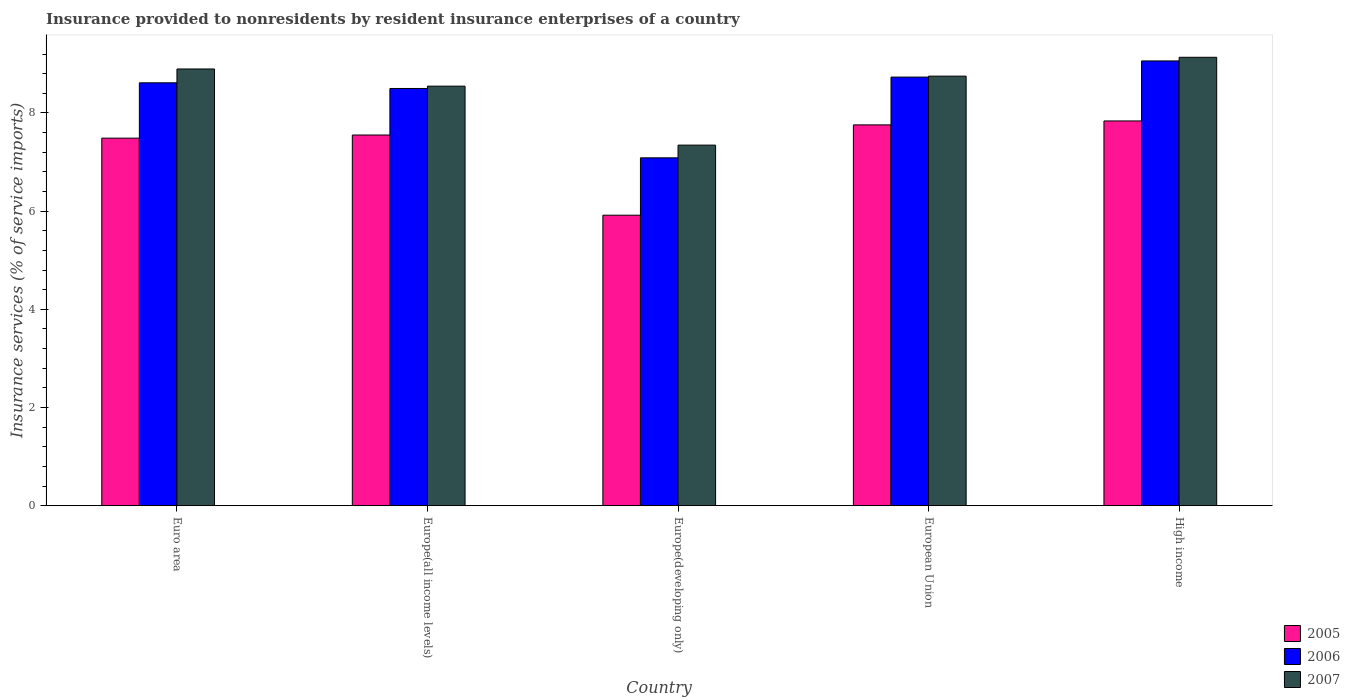How many different coloured bars are there?
Provide a short and direct response. 3. Are the number of bars per tick equal to the number of legend labels?
Give a very brief answer. Yes. What is the label of the 1st group of bars from the left?
Your answer should be very brief. Euro area. In how many cases, is the number of bars for a given country not equal to the number of legend labels?
Provide a succinct answer. 0. What is the insurance provided to nonresidents in 2006 in Europe(all income levels)?
Offer a very short reply. 8.5. Across all countries, what is the maximum insurance provided to nonresidents in 2005?
Make the answer very short. 7.84. Across all countries, what is the minimum insurance provided to nonresidents in 2006?
Make the answer very short. 7.09. In which country was the insurance provided to nonresidents in 2005 maximum?
Offer a terse response. High income. In which country was the insurance provided to nonresidents in 2005 minimum?
Ensure brevity in your answer.  Europe(developing only). What is the total insurance provided to nonresidents in 2005 in the graph?
Your answer should be very brief. 36.55. What is the difference between the insurance provided to nonresidents in 2005 in Europe(all income levels) and that in Europe(developing only)?
Your answer should be very brief. 1.63. What is the difference between the insurance provided to nonresidents in 2005 in European Union and the insurance provided to nonresidents in 2006 in Europe(all income levels)?
Offer a very short reply. -0.74. What is the average insurance provided to nonresidents in 2007 per country?
Your answer should be very brief. 8.53. What is the difference between the insurance provided to nonresidents of/in 2005 and insurance provided to nonresidents of/in 2007 in European Union?
Keep it short and to the point. -0.99. In how many countries, is the insurance provided to nonresidents in 2005 greater than 6.8 %?
Your answer should be compact. 4. What is the ratio of the insurance provided to nonresidents in 2007 in Europe(all income levels) to that in High income?
Keep it short and to the point. 0.94. Is the difference between the insurance provided to nonresidents in 2005 in Europe(all income levels) and European Union greater than the difference between the insurance provided to nonresidents in 2007 in Europe(all income levels) and European Union?
Provide a succinct answer. No. What is the difference between the highest and the second highest insurance provided to nonresidents in 2005?
Make the answer very short. -0.21. What is the difference between the highest and the lowest insurance provided to nonresidents in 2005?
Make the answer very short. 1.92. What does the 3rd bar from the left in High income represents?
Offer a very short reply. 2007. How many countries are there in the graph?
Provide a succinct answer. 5. What is the difference between two consecutive major ticks on the Y-axis?
Keep it short and to the point. 2. Are the values on the major ticks of Y-axis written in scientific E-notation?
Ensure brevity in your answer.  No. Does the graph contain any zero values?
Your answer should be compact. No. Where does the legend appear in the graph?
Keep it short and to the point. Bottom right. What is the title of the graph?
Keep it short and to the point. Insurance provided to nonresidents by resident insurance enterprises of a country. What is the label or title of the Y-axis?
Offer a very short reply. Insurance services (% of service imports). What is the Insurance services (% of service imports) in 2005 in Euro area?
Your response must be concise. 7.49. What is the Insurance services (% of service imports) of 2006 in Euro area?
Provide a short and direct response. 8.61. What is the Insurance services (% of service imports) of 2007 in Euro area?
Your response must be concise. 8.9. What is the Insurance services (% of service imports) of 2005 in Europe(all income levels)?
Your answer should be compact. 7.55. What is the Insurance services (% of service imports) of 2006 in Europe(all income levels)?
Your response must be concise. 8.5. What is the Insurance services (% of service imports) in 2007 in Europe(all income levels)?
Your response must be concise. 8.55. What is the Insurance services (% of service imports) in 2005 in Europe(developing only)?
Your response must be concise. 5.92. What is the Insurance services (% of service imports) in 2006 in Europe(developing only)?
Keep it short and to the point. 7.09. What is the Insurance services (% of service imports) of 2007 in Europe(developing only)?
Provide a succinct answer. 7.34. What is the Insurance services (% of service imports) of 2005 in European Union?
Give a very brief answer. 7.76. What is the Insurance services (% of service imports) of 2006 in European Union?
Ensure brevity in your answer.  8.73. What is the Insurance services (% of service imports) in 2007 in European Union?
Your answer should be very brief. 8.75. What is the Insurance services (% of service imports) of 2005 in High income?
Offer a very short reply. 7.84. What is the Insurance services (% of service imports) in 2006 in High income?
Your answer should be very brief. 9.06. What is the Insurance services (% of service imports) of 2007 in High income?
Your answer should be compact. 9.13. Across all countries, what is the maximum Insurance services (% of service imports) of 2005?
Keep it short and to the point. 7.84. Across all countries, what is the maximum Insurance services (% of service imports) of 2006?
Keep it short and to the point. 9.06. Across all countries, what is the maximum Insurance services (% of service imports) in 2007?
Keep it short and to the point. 9.13. Across all countries, what is the minimum Insurance services (% of service imports) in 2005?
Provide a succinct answer. 5.92. Across all countries, what is the minimum Insurance services (% of service imports) of 2006?
Provide a succinct answer. 7.09. Across all countries, what is the minimum Insurance services (% of service imports) in 2007?
Your answer should be compact. 7.34. What is the total Insurance services (% of service imports) of 2005 in the graph?
Provide a short and direct response. 36.55. What is the total Insurance services (% of service imports) of 2006 in the graph?
Provide a succinct answer. 41.99. What is the total Insurance services (% of service imports) in 2007 in the graph?
Your answer should be compact. 42.67. What is the difference between the Insurance services (% of service imports) of 2005 in Euro area and that in Europe(all income levels)?
Your answer should be compact. -0.06. What is the difference between the Insurance services (% of service imports) of 2006 in Euro area and that in Europe(all income levels)?
Provide a short and direct response. 0.12. What is the difference between the Insurance services (% of service imports) in 2007 in Euro area and that in Europe(all income levels)?
Make the answer very short. 0.35. What is the difference between the Insurance services (% of service imports) in 2005 in Euro area and that in Europe(developing only)?
Give a very brief answer. 1.57. What is the difference between the Insurance services (% of service imports) in 2006 in Euro area and that in Europe(developing only)?
Keep it short and to the point. 1.53. What is the difference between the Insurance services (% of service imports) in 2007 in Euro area and that in Europe(developing only)?
Offer a terse response. 1.55. What is the difference between the Insurance services (% of service imports) of 2005 in Euro area and that in European Union?
Your answer should be very brief. -0.27. What is the difference between the Insurance services (% of service imports) of 2006 in Euro area and that in European Union?
Make the answer very short. -0.12. What is the difference between the Insurance services (% of service imports) in 2007 in Euro area and that in European Union?
Offer a very short reply. 0.15. What is the difference between the Insurance services (% of service imports) in 2005 in Euro area and that in High income?
Offer a terse response. -0.35. What is the difference between the Insurance services (% of service imports) in 2006 in Euro area and that in High income?
Your answer should be compact. -0.45. What is the difference between the Insurance services (% of service imports) of 2007 in Euro area and that in High income?
Offer a very short reply. -0.24. What is the difference between the Insurance services (% of service imports) of 2005 in Europe(all income levels) and that in Europe(developing only)?
Give a very brief answer. 1.63. What is the difference between the Insurance services (% of service imports) in 2006 in Europe(all income levels) and that in Europe(developing only)?
Provide a succinct answer. 1.41. What is the difference between the Insurance services (% of service imports) in 2007 in Europe(all income levels) and that in Europe(developing only)?
Provide a short and direct response. 1.2. What is the difference between the Insurance services (% of service imports) in 2005 in Europe(all income levels) and that in European Union?
Provide a succinct answer. -0.21. What is the difference between the Insurance services (% of service imports) of 2006 in Europe(all income levels) and that in European Union?
Your response must be concise. -0.23. What is the difference between the Insurance services (% of service imports) of 2007 in Europe(all income levels) and that in European Union?
Your answer should be very brief. -0.2. What is the difference between the Insurance services (% of service imports) in 2005 in Europe(all income levels) and that in High income?
Give a very brief answer. -0.29. What is the difference between the Insurance services (% of service imports) of 2006 in Europe(all income levels) and that in High income?
Your response must be concise. -0.56. What is the difference between the Insurance services (% of service imports) in 2007 in Europe(all income levels) and that in High income?
Your answer should be very brief. -0.59. What is the difference between the Insurance services (% of service imports) in 2005 in Europe(developing only) and that in European Union?
Offer a terse response. -1.84. What is the difference between the Insurance services (% of service imports) in 2006 in Europe(developing only) and that in European Union?
Keep it short and to the point. -1.64. What is the difference between the Insurance services (% of service imports) in 2007 in Europe(developing only) and that in European Union?
Provide a succinct answer. -1.41. What is the difference between the Insurance services (% of service imports) of 2005 in Europe(developing only) and that in High income?
Make the answer very short. -1.92. What is the difference between the Insurance services (% of service imports) in 2006 in Europe(developing only) and that in High income?
Provide a succinct answer. -1.97. What is the difference between the Insurance services (% of service imports) of 2007 in Europe(developing only) and that in High income?
Your response must be concise. -1.79. What is the difference between the Insurance services (% of service imports) in 2005 in European Union and that in High income?
Your response must be concise. -0.08. What is the difference between the Insurance services (% of service imports) in 2006 in European Union and that in High income?
Offer a very short reply. -0.33. What is the difference between the Insurance services (% of service imports) in 2007 in European Union and that in High income?
Offer a terse response. -0.38. What is the difference between the Insurance services (% of service imports) in 2005 in Euro area and the Insurance services (% of service imports) in 2006 in Europe(all income levels)?
Make the answer very short. -1.01. What is the difference between the Insurance services (% of service imports) of 2005 in Euro area and the Insurance services (% of service imports) of 2007 in Europe(all income levels)?
Ensure brevity in your answer.  -1.06. What is the difference between the Insurance services (% of service imports) in 2006 in Euro area and the Insurance services (% of service imports) in 2007 in Europe(all income levels)?
Your answer should be compact. 0.07. What is the difference between the Insurance services (% of service imports) of 2005 in Euro area and the Insurance services (% of service imports) of 2006 in Europe(developing only)?
Your answer should be compact. 0.4. What is the difference between the Insurance services (% of service imports) in 2005 in Euro area and the Insurance services (% of service imports) in 2007 in Europe(developing only)?
Your response must be concise. 0.14. What is the difference between the Insurance services (% of service imports) of 2006 in Euro area and the Insurance services (% of service imports) of 2007 in Europe(developing only)?
Offer a terse response. 1.27. What is the difference between the Insurance services (% of service imports) in 2005 in Euro area and the Insurance services (% of service imports) in 2006 in European Union?
Make the answer very short. -1.24. What is the difference between the Insurance services (% of service imports) of 2005 in Euro area and the Insurance services (% of service imports) of 2007 in European Union?
Provide a succinct answer. -1.26. What is the difference between the Insurance services (% of service imports) in 2006 in Euro area and the Insurance services (% of service imports) in 2007 in European Union?
Offer a terse response. -0.14. What is the difference between the Insurance services (% of service imports) of 2005 in Euro area and the Insurance services (% of service imports) of 2006 in High income?
Your answer should be compact. -1.57. What is the difference between the Insurance services (% of service imports) of 2005 in Euro area and the Insurance services (% of service imports) of 2007 in High income?
Your answer should be compact. -1.65. What is the difference between the Insurance services (% of service imports) of 2006 in Euro area and the Insurance services (% of service imports) of 2007 in High income?
Your answer should be compact. -0.52. What is the difference between the Insurance services (% of service imports) in 2005 in Europe(all income levels) and the Insurance services (% of service imports) in 2006 in Europe(developing only)?
Offer a terse response. 0.47. What is the difference between the Insurance services (% of service imports) in 2005 in Europe(all income levels) and the Insurance services (% of service imports) in 2007 in Europe(developing only)?
Your answer should be compact. 0.21. What is the difference between the Insurance services (% of service imports) of 2006 in Europe(all income levels) and the Insurance services (% of service imports) of 2007 in Europe(developing only)?
Your response must be concise. 1.15. What is the difference between the Insurance services (% of service imports) of 2005 in Europe(all income levels) and the Insurance services (% of service imports) of 2006 in European Union?
Your answer should be very brief. -1.18. What is the difference between the Insurance services (% of service imports) of 2005 in Europe(all income levels) and the Insurance services (% of service imports) of 2007 in European Union?
Your response must be concise. -1.2. What is the difference between the Insurance services (% of service imports) of 2006 in Europe(all income levels) and the Insurance services (% of service imports) of 2007 in European Union?
Ensure brevity in your answer.  -0.25. What is the difference between the Insurance services (% of service imports) of 2005 in Europe(all income levels) and the Insurance services (% of service imports) of 2006 in High income?
Provide a short and direct response. -1.51. What is the difference between the Insurance services (% of service imports) in 2005 in Europe(all income levels) and the Insurance services (% of service imports) in 2007 in High income?
Make the answer very short. -1.58. What is the difference between the Insurance services (% of service imports) of 2006 in Europe(all income levels) and the Insurance services (% of service imports) of 2007 in High income?
Provide a succinct answer. -0.64. What is the difference between the Insurance services (% of service imports) of 2005 in Europe(developing only) and the Insurance services (% of service imports) of 2006 in European Union?
Give a very brief answer. -2.81. What is the difference between the Insurance services (% of service imports) in 2005 in Europe(developing only) and the Insurance services (% of service imports) in 2007 in European Union?
Provide a succinct answer. -2.83. What is the difference between the Insurance services (% of service imports) in 2006 in Europe(developing only) and the Insurance services (% of service imports) in 2007 in European Union?
Provide a succinct answer. -1.66. What is the difference between the Insurance services (% of service imports) in 2005 in Europe(developing only) and the Insurance services (% of service imports) in 2006 in High income?
Your response must be concise. -3.14. What is the difference between the Insurance services (% of service imports) in 2005 in Europe(developing only) and the Insurance services (% of service imports) in 2007 in High income?
Ensure brevity in your answer.  -3.22. What is the difference between the Insurance services (% of service imports) of 2006 in Europe(developing only) and the Insurance services (% of service imports) of 2007 in High income?
Offer a very short reply. -2.05. What is the difference between the Insurance services (% of service imports) in 2005 in European Union and the Insurance services (% of service imports) in 2006 in High income?
Offer a terse response. -1.3. What is the difference between the Insurance services (% of service imports) of 2005 in European Union and the Insurance services (% of service imports) of 2007 in High income?
Offer a terse response. -1.38. What is the difference between the Insurance services (% of service imports) of 2006 in European Union and the Insurance services (% of service imports) of 2007 in High income?
Provide a succinct answer. -0.4. What is the average Insurance services (% of service imports) in 2005 per country?
Keep it short and to the point. 7.31. What is the average Insurance services (% of service imports) in 2006 per country?
Ensure brevity in your answer.  8.4. What is the average Insurance services (% of service imports) of 2007 per country?
Provide a short and direct response. 8.53. What is the difference between the Insurance services (% of service imports) in 2005 and Insurance services (% of service imports) in 2006 in Euro area?
Provide a short and direct response. -1.13. What is the difference between the Insurance services (% of service imports) of 2005 and Insurance services (% of service imports) of 2007 in Euro area?
Keep it short and to the point. -1.41. What is the difference between the Insurance services (% of service imports) in 2006 and Insurance services (% of service imports) in 2007 in Euro area?
Give a very brief answer. -0.28. What is the difference between the Insurance services (% of service imports) of 2005 and Insurance services (% of service imports) of 2006 in Europe(all income levels)?
Keep it short and to the point. -0.95. What is the difference between the Insurance services (% of service imports) of 2005 and Insurance services (% of service imports) of 2007 in Europe(all income levels)?
Your answer should be compact. -1. What is the difference between the Insurance services (% of service imports) in 2006 and Insurance services (% of service imports) in 2007 in Europe(all income levels)?
Provide a short and direct response. -0.05. What is the difference between the Insurance services (% of service imports) in 2005 and Insurance services (% of service imports) in 2006 in Europe(developing only)?
Keep it short and to the point. -1.17. What is the difference between the Insurance services (% of service imports) of 2005 and Insurance services (% of service imports) of 2007 in Europe(developing only)?
Ensure brevity in your answer.  -1.43. What is the difference between the Insurance services (% of service imports) in 2006 and Insurance services (% of service imports) in 2007 in Europe(developing only)?
Your answer should be compact. -0.26. What is the difference between the Insurance services (% of service imports) in 2005 and Insurance services (% of service imports) in 2006 in European Union?
Offer a terse response. -0.97. What is the difference between the Insurance services (% of service imports) of 2005 and Insurance services (% of service imports) of 2007 in European Union?
Give a very brief answer. -0.99. What is the difference between the Insurance services (% of service imports) in 2006 and Insurance services (% of service imports) in 2007 in European Union?
Offer a terse response. -0.02. What is the difference between the Insurance services (% of service imports) of 2005 and Insurance services (% of service imports) of 2006 in High income?
Offer a very short reply. -1.22. What is the difference between the Insurance services (% of service imports) of 2005 and Insurance services (% of service imports) of 2007 in High income?
Keep it short and to the point. -1.3. What is the difference between the Insurance services (% of service imports) in 2006 and Insurance services (% of service imports) in 2007 in High income?
Offer a terse response. -0.07. What is the ratio of the Insurance services (% of service imports) of 2005 in Euro area to that in Europe(all income levels)?
Ensure brevity in your answer.  0.99. What is the ratio of the Insurance services (% of service imports) in 2006 in Euro area to that in Europe(all income levels)?
Your answer should be very brief. 1.01. What is the ratio of the Insurance services (% of service imports) of 2007 in Euro area to that in Europe(all income levels)?
Make the answer very short. 1.04. What is the ratio of the Insurance services (% of service imports) in 2005 in Euro area to that in Europe(developing only)?
Offer a very short reply. 1.27. What is the ratio of the Insurance services (% of service imports) in 2006 in Euro area to that in Europe(developing only)?
Give a very brief answer. 1.22. What is the ratio of the Insurance services (% of service imports) in 2007 in Euro area to that in Europe(developing only)?
Provide a short and direct response. 1.21. What is the ratio of the Insurance services (% of service imports) of 2005 in Euro area to that in European Union?
Offer a terse response. 0.97. What is the ratio of the Insurance services (% of service imports) in 2006 in Euro area to that in European Union?
Provide a succinct answer. 0.99. What is the ratio of the Insurance services (% of service imports) in 2007 in Euro area to that in European Union?
Offer a very short reply. 1.02. What is the ratio of the Insurance services (% of service imports) in 2005 in Euro area to that in High income?
Keep it short and to the point. 0.96. What is the ratio of the Insurance services (% of service imports) of 2006 in Euro area to that in High income?
Give a very brief answer. 0.95. What is the ratio of the Insurance services (% of service imports) of 2007 in Euro area to that in High income?
Provide a succinct answer. 0.97. What is the ratio of the Insurance services (% of service imports) of 2005 in Europe(all income levels) to that in Europe(developing only)?
Your answer should be very brief. 1.28. What is the ratio of the Insurance services (% of service imports) in 2006 in Europe(all income levels) to that in Europe(developing only)?
Provide a succinct answer. 1.2. What is the ratio of the Insurance services (% of service imports) of 2007 in Europe(all income levels) to that in Europe(developing only)?
Give a very brief answer. 1.16. What is the ratio of the Insurance services (% of service imports) of 2005 in Europe(all income levels) to that in European Union?
Your response must be concise. 0.97. What is the ratio of the Insurance services (% of service imports) of 2006 in Europe(all income levels) to that in European Union?
Provide a short and direct response. 0.97. What is the ratio of the Insurance services (% of service imports) in 2007 in Europe(all income levels) to that in European Union?
Offer a terse response. 0.98. What is the ratio of the Insurance services (% of service imports) of 2005 in Europe(all income levels) to that in High income?
Give a very brief answer. 0.96. What is the ratio of the Insurance services (% of service imports) of 2006 in Europe(all income levels) to that in High income?
Your answer should be very brief. 0.94. What is the ratio of the Insurance services (% of service imports) of 2007 in Europe(all income levels) to that in High income?
Offer a very short reply. 0.94. What is the ratio of the Insurance services (% of service imports) in 2005 in Europe(developing only) to that in European Union?
Your answer should be very brief. 0.76. What is the ratio of the Insurance services (% of service imports) in 2006 in Europe(developing only) to that in European Union?
Ensure brevity in your answer.  0.81. What is the ratio of the Insurance services (% of service imports) of 2007 in Europe(developing only) to that in European Union?
Ensure brevity in your answer.  0.84. What is the ratio of the Insurance services (% of service imports) in 2005 in Europe(developing only) to that in High income?
Provide a succinct answer. 0.76. What is the ratio of the Insurance services (% of service imports) in 2006 in Europe(developing only) to that in High income?
Keep it short and to the point. 0.78. What is the ratio of the Insurance services (% of service imports) of 2007 in Europe(developing only) to that in High income?
Your answer should be compact. 0.8. What is the ratio of the Insurance services (% of service imports) in 2005 in European Union to that in High income?
Keep it short and to the point. 0.99. What is the ratio of the Insurance services (% of service imports) in 2006 in European Union to that in High income?
Offer a very short reply. 0.96. What is the ratio of the Insurance services (% of service imports) of 2007 in European Union to that in High income?
Offer a terse response. 0.96. What is the difference between the highest and the second highest Insurance services (% of service imports) in 2005?
Provide a succinct answer. 0.08. What is the difference between the highest and the second highest Insurance services (% of service imports) in 2006?
Your response must be concise. 0.33. What is the difference between the highest and the second highest Insurance services (% of service imports) of 2007?
Offer a very short reply. 0.24. What is the difference between the highest and the lowest Insurance services (% of service imports) of 2005?
Provide a succinct answer. 1.92. What is the difference between the highest and the lowest Insurance services (% of service imports) in 2006?
Provide a short and direct response. 1.97. What is the difference between the highest and the lowest Insurance services (% of service imports) in 2007?
Offer a terse response. 1.79. 